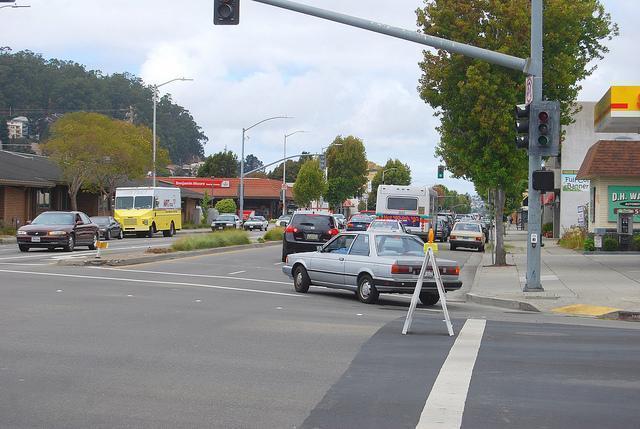What type of traffic does this road have?
Select the accurate response from the four choices given to answer the question.
Options: Heavy, tractor, herded animal, light. Heavy. 